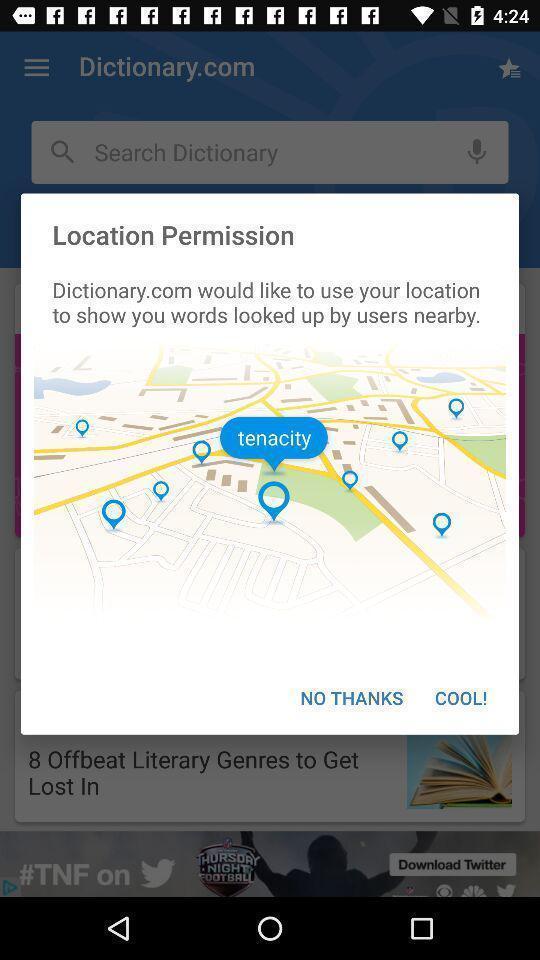What details can you identify in this image? Pop-up showing location permission for the dictionary app. 